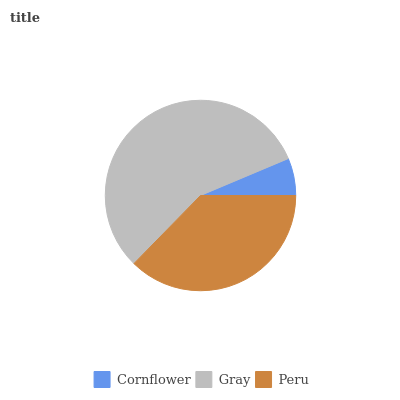Is Cornflower the minimum?
Answer yes or no. Yes. Is Gray the maximum?
Answer yes or no. Yes. Is Peru the minimum?
Answer yes or no. No. Is Peru the maximum?
Answer yes or no. No. Is Gray greater than Peru?
Answer yes or no. Yes. Is Peru less than Gray?
Answer yes or no. Yes. Is Peru greater than Gray?
Answer yes or no. No. Is Gray less than Peru?
Answer yes or no. No. Is Peru the high median?
Answer yes or no. Yes. Is Peru the low median?
Answer yes or no. Yes. Is Gray the high median?
Answer yes or no. No. Is Gray the low median?
Answer yes or no. No. 